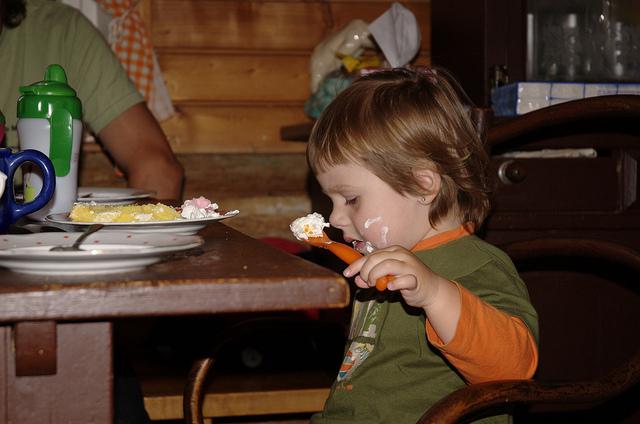What is the little kid holding in one of his hands?
Give a very brief answer. Spoon. What is the little girl trying to do?
Concise answer only. Eat. What color is dominates this shot?
Concise answer only. Brown. What is the kid eating?
Keep it brief. Cake. How many hotdogs are on the plates?
Be succinct. 0. What is the child on the right dressed up as?
Quick response, please. Nothing. What color is the handle?
Answer briefly. Orange. Is the child going to drop the cake?
Answer briefly. No. What pattern is the orange and white cloth?
Answer briefly. Checkered. What color is the boy's shirt?
Answer briefly. Green. Is this person wearing glasses?
Short answer required. No. What are these kids cups called?
Keep it brief. Sippy cup. What kind of beverages are in the photo?
Give a very brief answer. Juice. 